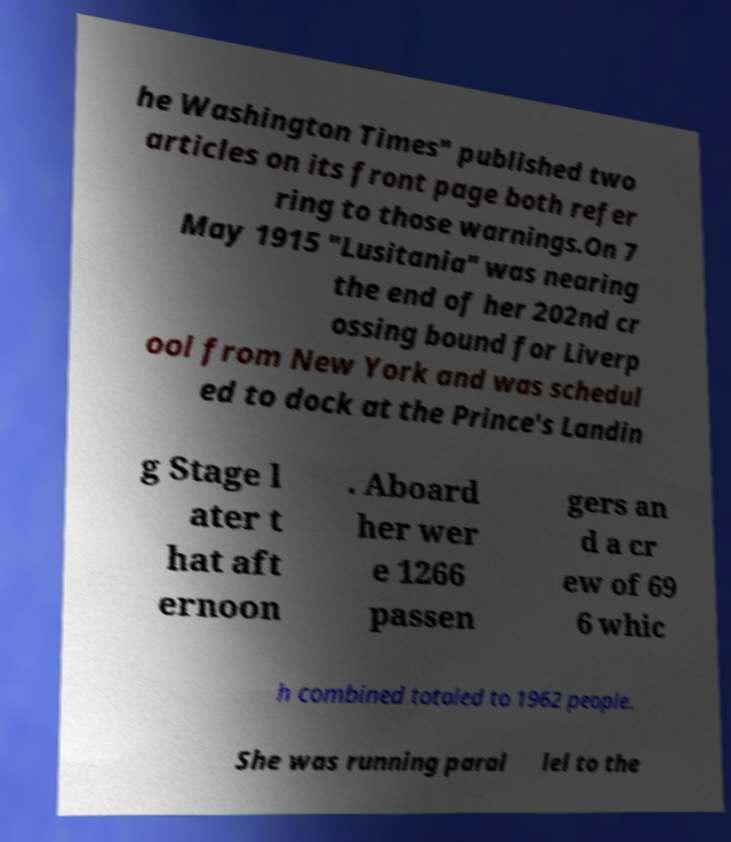There's text embedded in this image that I need extracted. Can you transcribe it verbatim? he Washington Times" published two articles on its front page both refer ring to those warnings.On 7 May 1915 "Lusitania" was nearing the end of her 202nd cr ossing bound for Liverp ool from New York and was schedul ed to dock at the Prince's Landin g Stage l ater t hat aft ernoon . Aboard her wer e 1266 passen gers an d a cr ew of 69 6 whic h combined totaled to 1962 people. She was running paral lel to the 